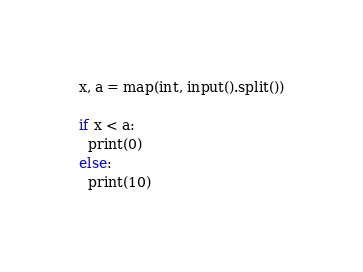<code> <loc_0><loc_0><loc_500><loc_500><_Python_>x, a = map(int, input().split())

if x < a:
  print(0)
else:
  print(10)</code> 